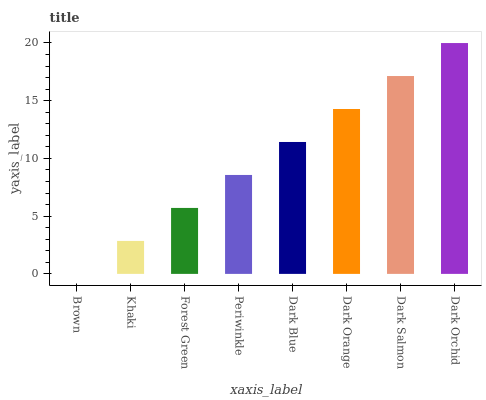Is Khaki the minimum?
Answer yes or no. No. Is Khaki the maximum?
Answer yes or no. No. Is Khaki greater than Brown?
Answer yes or no. Yes. Is Brown less than Khaki?
Answer yes or no. Yes. Is Brown greater than Khaki?
Answer yes or no. No. Is Khaki less than Brown?
Answer yes or no. No. Is Dark Blue the high median?
Answer yes or no. Yes. Is Periwinkle the low median?
Answer yes or no. Yes. Is Khaki the high median?
Answer yes or no. No. Is Dark Orchid the low median?
Answer yes or no. No. 